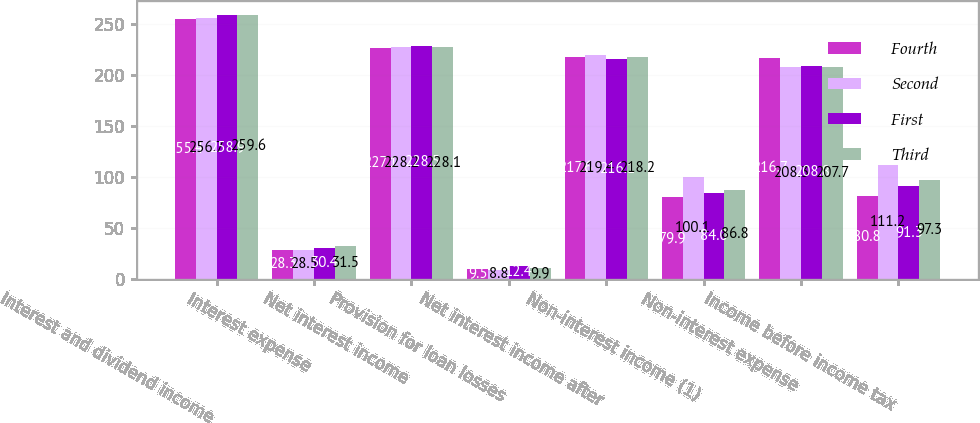<chart> <loc_0><loc_0><loc_500><loc_500><stacked_bar_chart><ecel><fcel>Interest and dividend income<fcel>Interest expense<fcel>Net interest income<fcel>Provision for loan losses<fcel>Net interest income after<fcel>Non-interest income (1)<fcel>Non-interest expense<fcel>Income before income tax<nl><fcel>Fourth<fcel>255.4<fcel>28.3<fcel>227.1<fcel>9.5<fcel>217.6<fcel>79.9<fcel>216.7<fcel>80.8<nl><fcel>Second<fcel>256.7<fcel>28.5<fcel>228.2<fcel>8.8<fcel>219.4<fcel>100.1<fcel>208.3<fcel>111.2<nl><fcel>First<fcel>258.9<fcel>30.4<fcel>228.5<fcel>12.4<fcel>216.1<fcel>84<fcel>208.8<fcel>91.3<nl><fcel>Third<fcel>259.6<fcel>31.5<fcel>228.1<fcel>9.9<fcel>218.2<fcel>86.8<fcel>207.7<fcel>97.3<nl></chart> 